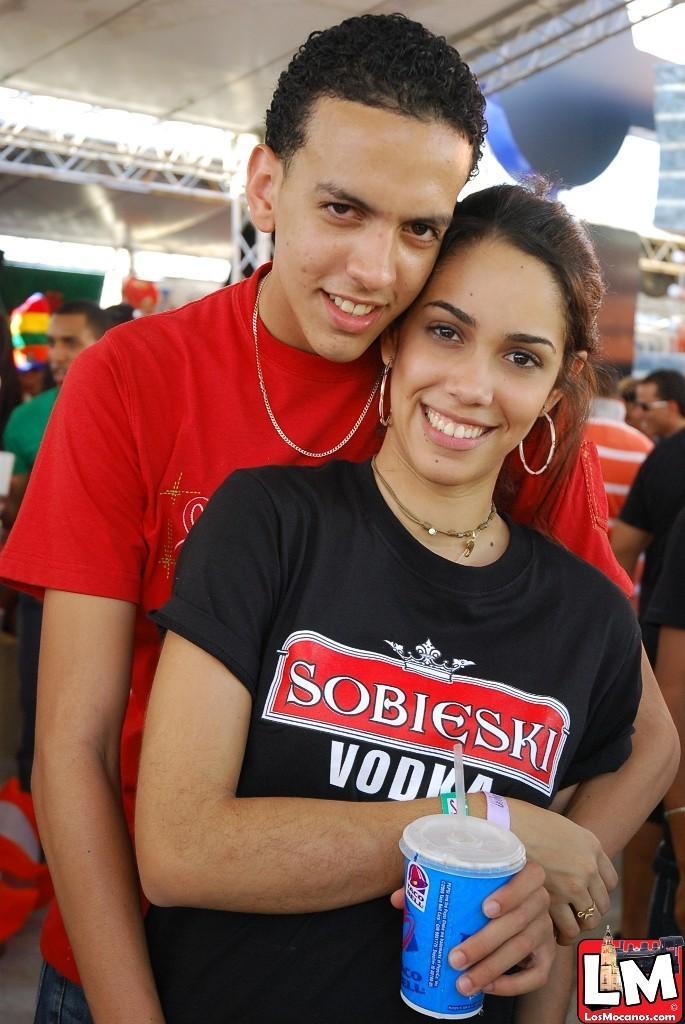In one or two sentences, can you explain what this image depicts? In the center of the image we can see a man and a lady are there. A lady is holding a bottle. In the background of the image we can see a group of people are there. At the top of the image roof is present. 